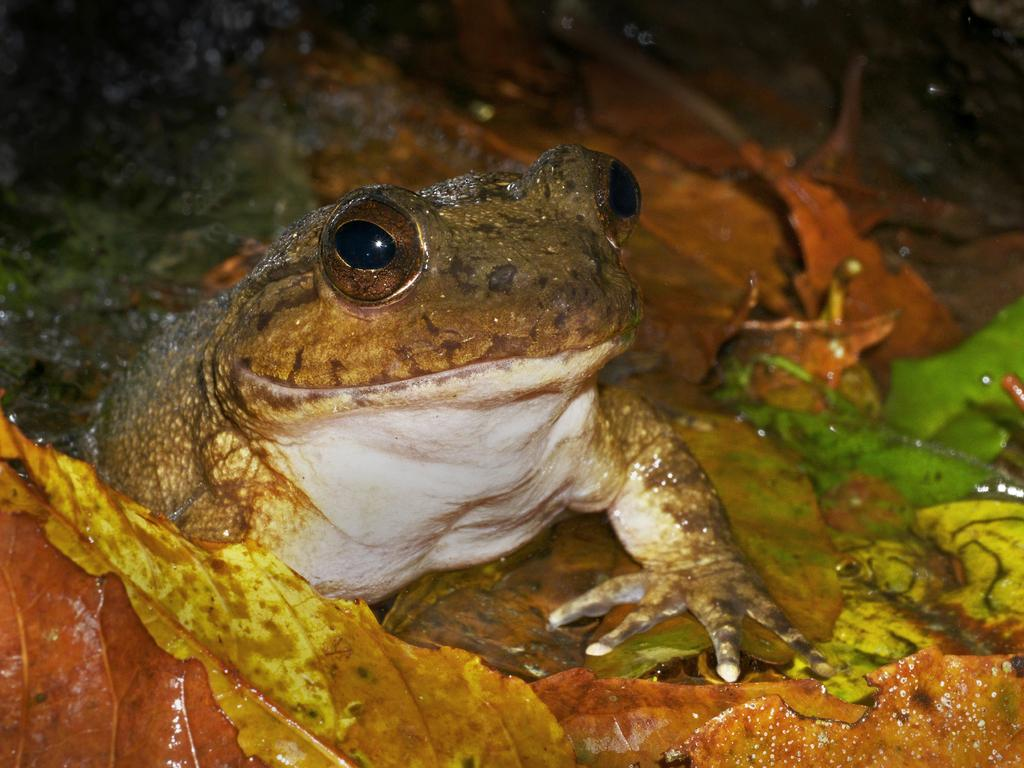What animal is present in the image? There is a frog in the image. Where is the frog located? The frog is on the leaves. Can you describe the position of the frog in the image? The frog is in the center of the image. What type of ghost can be seen interacting with the frog in the image? There is no ghost present in the image; it features a frog on the leaves. Are there any bears visible in the image? There are no bears present in the image. 